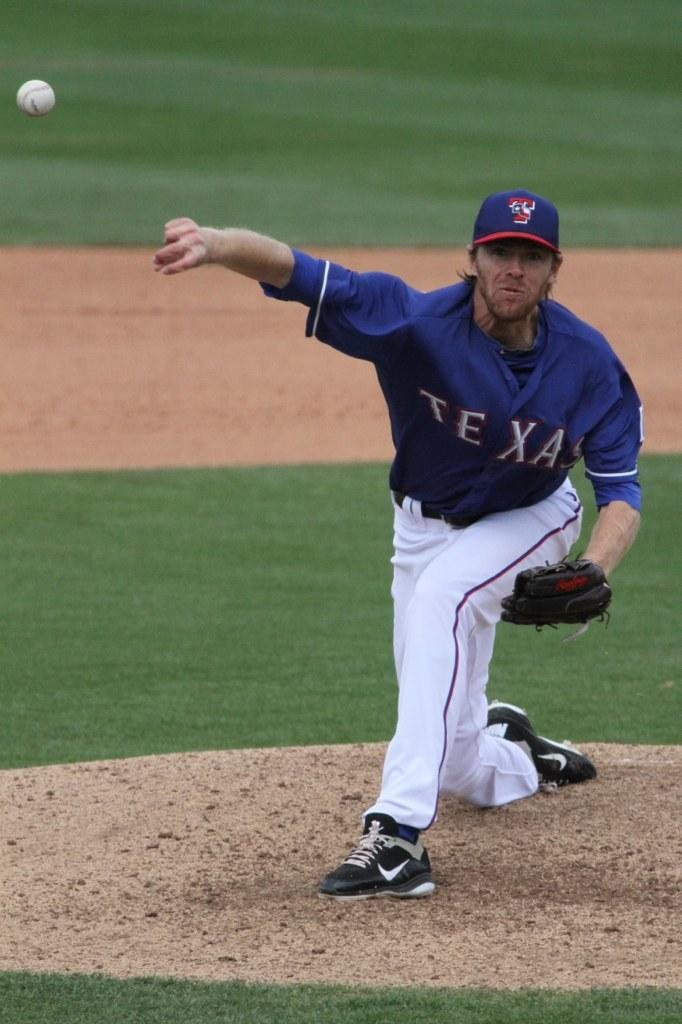<image>
Create a compact narrative representing the image presented. A photo of a pitcher for a baseball team in Texas. 